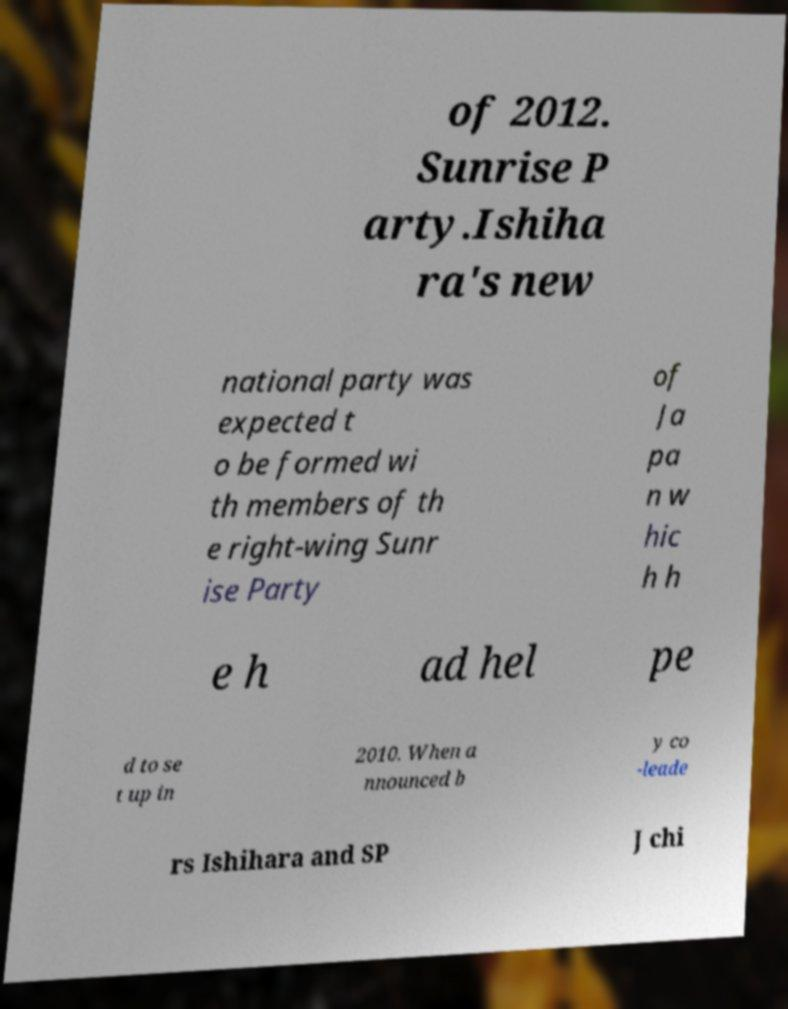Could you extract and type out the text from this image? of 2012. Sunrise P arty.Ishiha ra's new national party was expected t o be formed wi th members of th e right-wing Sunr ise Party of Ja pa n w hic h h e h ad hel pe d to se t up in 2010. When a nnounced b y co -leade rs Ishihara and SP J chi 